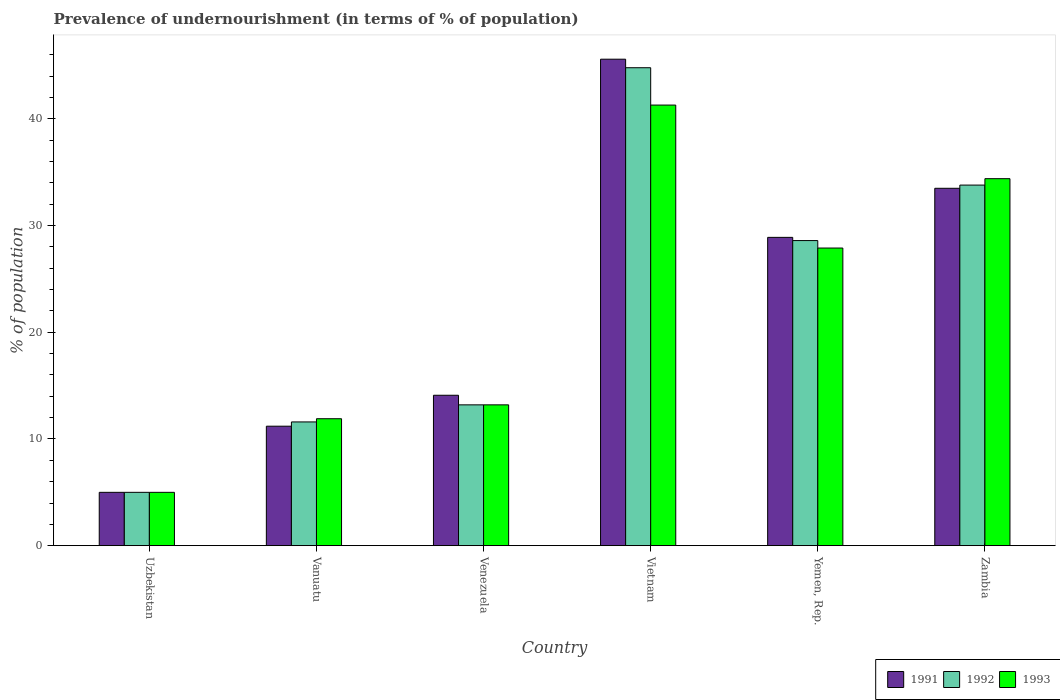How many groups of bars are there?
Make the answer very short. 6. Are the number of bars per tick equal to the number of legend labels?
Provide a short and direct response. Yes. How many bars are there on the 1st tick from the left?
Make the answer very short. 3. What is the label of the 5th group of bars from the left?
Make the answer very short. Yemen, Rep. In how many cases, is the number of bars for a given country not equal to the number of legend labels?
Give a very brief answer. 0. What is the percentage of undernourished population in 1993 in Venezuela?
Offer a very short reply. 13.2. Across all countries, what is the maximum percentage of undernourished population in 1991?
Provide a succinct answer. 45.6. In which country was the percentage of undernourished population in 1993 maximum?
Offer a very short reply. Vietnam. In which country was the percentage of undernourished population in 1993 minimum?
Your answer should be very brief. Uzbekistan. What is the total percentage of undernourished population in 1991 in the graph?
Your answer should be very brief. 138.3. What is the difference between the percentage of undernourished population in 1991 in Venezuela and that in Zambia?
Keep it short and to the point. -19.4. What is the difference between the percentage of undernourished population in 1991 in Venezuela and the percentage of undernourished population in 1993 in Zambia?
Offer a very short reply. -20.3. What is the average percentage of undernourished population in 1991 per country?
Provide a short and direct response. 23.05. What is the difference between the percentage of undernourished population of/in 1991 and percentage of undernourished population of/in 1993 in Venezuela?
Your response must be concise. 0.9. What is the ratio of the percentage of undernourished population in 1992 in Venezuela to that in Yemen, Rep.?
Provide a short and direct response. 0.46. Is the percentage of undernourished population in 1991 in Uzbekistan less than that in Vanuatu?
Make the answer very short. Yes. Is the difference between the percentage of undernourished population in 1991 in Vanuatu and Vietnam greater than the difference between the percentage of undernourished population in 1993 in Vanuatu and Vietnam?
Provide a succinct answer. No. What is the difference between the highest and the second highest percentage of undernourished population in 1991?
Keep it short and to the point. 4.6. What is the difference between the highest and the lowest percentage of undernourished population in 1992?
Offer a terse response. 39.8. In how many countries, is the percentage of undernourished population in 1993 greater than the average percentage of undernourished population in 1993 taken over all countries?
Your answer should be very brief. 3. Is the sum of the percentage of undernourished population in 1992 in Uzbekistan and Vanuatu greater than the maximum percentage of undernourished population in 1993 across all countries?
Offer a terse response. No. Is it the case that in every country, the sum of the percentage of undernourished population in 1993 and percentage of undernourished population in 1991 is greater than the percentage of undernourished population in 1992?
Make the answer very short. Yes. How many bars are there?
Provide a short and direct response. 18. Are all the bars in the graph horizontal?
Offer a very short reply. No. How many countries are there in the graph?
Your answer should be compact. 6. Where does the legend appear in the graph?
Provide a short and direct response. Bottom right. What is the title of the graph?
Offer a very short reply. Prevalence of undernourishment (in terms of % of population). What is the label or title of the X-axis?
Keep it short and to the point. Country. What is the label or title of the Y-axis?
Make the answer very short. % of population. What is the % of population in 1993 in Uzbekistan?
Ensure brevity in your answer.  5. What is the % of population of 1991 in Vanuatu?
Your answer should be very brief. 11.2. What is the % of population of 1992 in Vanuatu?
Your response must be concise. 11.6. What is the % of population of 1991 in Venezuela?
Ensure brevity in your answer.  14.1. What is the % of population in 1992 in Venezuela?
Your answer should be compact. 13.2. What is the % of population in 1993 in Venezuela?
Give a very brief answer. 13.2. What is the % of population of 1991 in Vietnam?
Your answer should be compact. 45.6. What is the % of population in 1992 in Vietnam?
Provide a succinct answer. 44.8. What is the % of population in 1993 in Vietnam?
Your answer should be very brief. 41.3. What is the % of population of 1991 in Yemen, Rep.?
Provide a short and direct response. 28.9. What is the % of population in 1992 in Yemen, Rep.?
Your answer should be very brief. 28.6. What is the % of population of 1993 in Yemen, Rep.?
Provide a succinct answer. 27.9. What is the % of population of 1991 in Zambia?
Offer a very short reply. 33.5. What is the % of population of 1992 in Zambia?
Offer a terse response. 33.8. What is the % of population in 1993 in Zambia?
Provide a succinct answer. 34.4. Across all countries, what is the maximum % of population of 1991?
Your response must be concise. 45.6. Across all countries, what is the maximum % of population in 1992?
Your response must be concise. 44.8. Across all countries, what is the maximum % of population in 1993?
Provide a succinct answer. 41.3. Across all countries, what is the minimum % of population in 1992?
Ensure brevity in your answer.  5. Across all countries, what is the minimum % of population of 1993?
Keep it short and to the point. 5. What is the total % of population in 1991 in the graph?
Offer a terse response. 138.3. What is the total % of population of 1992 in the graph?
Your answer should be compact. 137. What is the total % of population in 1993 in the graph?
Make the answer very short. 133.7. What is the difference between the % of population of 1993 in Uzbekistan and that in Vanuatu?
Keep it short and to the point. -6.9. What is the difference between the % of population of 1991 in Uzbekistan and that in Venezuela?
Your answer should be compact. -9.1. What is the difference between the % of population of 1992 in Uzbekistan and that in Venezuela?
Offer a very short reply. -8.2. What is the difference between the % of population in 1993 in Uzbekistan and that in Venezuela?
Offer a terse response. -8.2. What is the difference between the % of population of 1991 in Uzbekistan and that in Vietnam?
Provide a short and direct response. -40.6. What is the difference between the % of population in 1992 in Uzbekistan and that in Vietnam?
Your answer should be very brief. -39.8. What is the difference between the % of population in 1993 in Uzbekistan and that in Vietnam?
Provide a short and direct response. -36.3. What is the difference between the % of population in 1991 in Uzbekistan and that in Yemen, Rep.?
Ensure brevity in your answer.  -23.9. What is the difference between the % of population in 1992 in Uzbekistan and that in Yemen, Rep.?
Give a very brief answer. -23.6. What is the difference between the % of population in 1993 in Uzbekistan and that in Yemen, Rep.?
Ensure brevity in your answer.  -22.9. What is the difference between the % of population in 1991 in Uzbekistan and that in Zambia?
Your response must be concise. -28.5. What is the difference between the % of population in 1992 in Uzbekistan and that in Zambia?
Offer a very short reply. -28.8. What is the difference between the % of population in 1993 in Uzbekistan and that in Zambia?
Provide a short and direct response. -29.4. What is the difference between the % of population of 1991 in Vanuatu and that in Venezuela?
Your answer should be very brief. -2.9. What is the difference between the % of population in 1992 in Vanuatu and that in Venezuela?
Make the answer very short. -1.6. What is the difference between the % of population in 1991 in Vanuatu and that in Vietnam?
Ensure brevity in your answer.  -34.4. What is the difference between the % of population in 1992 in Vanuatu and that in Vietnam?
Offer a very short reply. -33.2. What is the difference between the % of population in 1993 in Vanuatu and that in Vietnam?
Provide a succinct answer. -29.4. What is the difference between the % of population in 1991 in Vanuatu and that in Yemen, Rep.?
Ensure brevity in your answer.  -17.7. What is the difference between the % of population in 1993 in Vanuatu and that in Yemen, Rep.?
Your answer should be very brief. -16. What is the difference between the % of population in 1991 in Vanuatu and that in Zambia?
Offer a very short reply. -22.3. What is the difference between the % of population of 1992 in Vanuatu and that in Zambia?
Provide a short and direct response. -22.2. What is the difference between the % of population in 1993 in Vanuatu and that in Zambia?
Your response must be concise. -22.5. What is the difference between the % of population in 1991 in Venezuela and that in Vietnam?
Your answer should be very brief. -31.5. What is the difference between the % of population of 1992 in Venezuela and that in Vietnam?
Make the answer very short. -31.6. What is the difference between the % of population in 1993 in Venezuela and that in Vietnam?
Your response must be concise. -28.1. What is the difference between the % of population in 1991 in Venezuela and that in Yemen, Rep.?
Keep it short and to the point. -14.8. What is the difference between the % of population in 1992 in Venezuela and that in Yemen, Rep.?
Offer a terse response. -15.4. What is the difference between the % of population in 1993 in Venezuela and that in Yemen, Rep.?
Provide a short and direct response. -14.7. What is the difference between the % of population in 1991 in Venezuela and that in Zambia?
Your response must be concise. -19.4. What is the difference between the % of population of 1992 in Venezuela and that in Zambia?
Your answer should be compact. -20.6. What is the difference between the % of population of 1993 in Venezuela and that in Zambia?
Offer a terse response. -21.2. What is the difference between the % of population in 1992 in Vietnam and that in Zambia?
Keep it short and to the point. 11. What is the difference between the % of population of 1991 in Uzbekistan and the % of population of 1992 in Vanuatu?
Give a very brief answer. -6.6. What is the difference between the % of population in 1991 in Uzbekistan and the % of population in 1993 in Vanuatu?
Offer a very short reply. -6.9. What is the difference between the % of population of 1992 in Uzbekistan and the % of population of 1993 in Vanuatu?
Provide a short and direct response. -6.9. What is the difference between the % of population in 1992 in Uzbekistan and the % of population in 1993 in Venezuela?
Your answer should be compact. -8.2. What is the difference between the % of population in 1991 in Uzbekistan and the % of population in 1992 in Vietnam?
Provide a short and direct response. -39.8. What is the difference between the % of population of 1991 in Uzbekistan and the % of population of 1993 in Vietnam?
Provide a short and direct response. -36.3. What is the difference between the % of population of 1992 in Uzbekistan and the % of population of 1993 in Vietnam?
Provide a short and direct response. -36.3. What is the difference between the % of population of 1991 in Uzbekistan and the % of population of 1992 in Yemen, Rep.?
Offer a terse response. -23.6. What is the difference between the % of population of 1991 in Uzbekistan and the % of population of 1993 in Yemen, Rep.?
Your answer should be very brief. -22.9. What is the difference between the % of population in 1992 in Uzbekistan and the % of population in 1993 in Yemen, Rep.?
Your answer should be compact. -22.9. What is the difference between the % of population in 1991 in Uzbekistan and the % of population in 1992 in Zambia?
Provide a succinct answer. -28.8. What is the difference between the % of population in 1991 in Uzbekistan and the % of population in 1993 in Zambia?
Your response must be concise. -29.4. What is the difference between the % of population in 1992 in Uzbekistan and the % of population in 1993 in Zambia?
Provide a short and direct response. -29.4. What is the difference between the % of population in 1992 in Vanuatu and the % of population in 1993 in Venezuela?
Provide a short and direct response. -1.6. What is the difference between the % of population in 1991 in Vanuatu and the % of population in 1992 in Vietnam?
Your response must be concise. -33.6. What is the difference between the % of population in 1991 in Vanuatu and the % of population in 1993 in Vietnam?
Give a very brief answer. -30.1. What is the difference between the % of population of 1992 in Vanuatu and the % of population of 1993 in Vietnam?
Make the answer very short. -29.7. What is the difference between the % of population in 1991 in Vanuatu and the % of population in 1992 in Yemen, Rep.?
Your response must be concise. -17.4. What is the difference between the % of population in 1991 in Vanuatu and the % of population in 1993 in Yemen, Rep.?
Provide a succinct answer. -16.7. What is the difference between the % of population in 1992 in Vanuatu and the % of population in 1993 in Yemen, Rep.?
Offer a terse response. -16.3. What is the difference between the % of population of 1991 in Vanuatu and the % of population of 1992 in Zambia?
Give a very brief answer. -22.6. What is the difference between the % of population of 1991 in Vanuatu and the % of population of 1993 in Zambia?
Ensure brevity in your answer.  -23.2. What is the difference between the % of population of 1992 in Vanuatu and the % of population of 1993 in Zambia?
Your answer should be very brief. -22.8. What is the difference between the % of population in 1991 in Venezuela and the % of population in 1992 in Vietnam?
Keep it short and to the point. -30.7. What is the difference between the % of population of 1991 in Venezuela and the % of population of 1993 in Vietnam?
Your response must be concise. -27.2. What is the difference between the % of population in 1992 in Venezuela and the % of population in 1993 in Vietnam?
Make the answer very short. -28.1. What is the difference between the % of population of 1991 in Venezuela and the % of population of 1993 in Yemen, Rep.?
Offer a terse response. -13.8. What is the difference between the % of population of 1992 in Venezuela and the % of population of 1993 in Yemen, Rep.?
Your answer should be very brief. -14.7. What is the difference between the % of population in 1991 in Venezuela and the % of population in 1992 in Zambia?
Ensure brevity in your answer.  -19.7. What is the difference between the % of population of 1991 in Venezuela and the % of population of 1993 in Zambia?
Make the answer very short. -20.3. What is the difference between the % of population in 1992 in Venezuela and the % of population in 1993 in Zambia?
Offer a terse response. -21.2. What is the difference between the % of population of 1991 in Vietnam and the % of population of 1992 in Yemen, Rep.?
Keep it short and to the point. 17. What is the difference between the % of population in 1991 in Vietnam and the % of population in 1993 in Yemen, Rep.?
Your answer should be compact. 17.7. What is the difference between the % of population of 1991 in Vietnam and the % of population of 1992 in Zambia?
Keep it short and to the point. 11.8. What is the difference between the % of population in 1991 in Yemen, Rep. and the % of population in 1993 in Zambia?
Your answer should be very brief. -5.5. What is the average % of population of 1991 per country?
Give a very brief answer. 23.05. What is the average % of population in 1992 per country?
Provide a short and direct response. 22.83. What is the average % of population in 1993 per country?
Provide a short and direct response. 22.28. What is the difference between the % of population of 1992 and % of population of 1993 in Uzbekistan?
Give a very brief answer. 0. What is the difference between the % of population in 1992 and % of population in 1993 in Vanuatu?
Offer a terse response. -0.3. What is the difference between the % of population in 1991 and % of population in 1992 in Venezuela?
Offer a very short reply. 0.9. What is the difference between the % of population in 1991 and % of population in 1993 in Venezuela?
Provide a short and direct response. 0.9. What is the difference between the % of population of 1992 and % of population of 1993 in Venezuela?
Make the answer very short. 0. What is the difference between the % of population of 1991 and % of population of 1992 in Vietnam?
Your response must be concise. 0.8. What is the difference between the % of population in 1991 and % of population in 1993 in Vietnam?
Offer a very short reply. 4.3. What is the difference between the % of population of 1992 and % of population of 1993 in Vietnam?
Provide a short and direct response. 3.5. What is the difference between the % of population of 1991 and % of population of 1992 in Yemen, Rep.?
Ensure brevity in your answer.  0.3. What is the difference between the % of population in 1991 and % of population in 1993 in Zambia?
Ensure brevity in your answer.  -0.9. What is the ratio of the % of population in 1991 in Uzbekistan to that in Vanuatu?
Ensure brevity in your answer.  0.45. What is the ratio of the % of population of 1992 in Uzbekistan to that in Vanuatu?
Provide a short and direct response. 0.43. What is the ratio of the % of population of 1993 in Uzbekistan to that in Vanuatu?
Your response must be concise. 0.42. What is the ratio of the % of population in 1991 in Uzbekistan to that in Venezuela?
Give a very brief answer. 0.35. What is the ratio of the % of population of 1992 in Uzbekistan to that in Venezuela?
Ensure brevity in your answer.  0.38. What is the ratio of the % of population in 1993 in Uzbekistan to that in Venezuela?
Your response must be concise. 0.38. What is the ratio of the % of population of 1991 in Uzbekistan to that in Vietnam?
Provide a short and direct response. 0.11. What is the ratio of the % of population in 1992 in Uzbekistan to that in Vietnam?
Provide a short and direct response. 0.11. What is the ratio of the % of population in 1993 in Uzbekistan to that in Vietnam?
Give a very brief answer. 0.12. What is the ratio of the % of population in 1991 in Uzbekistan to that in Yemen, Rep.?
Provide a short and direct response. 0.17. What is the ratio of the % of population in 1992 in Uzbekistan to that in Yemen, Rep.?
Your answer should be compact. 0.17. What is the ratio of the % of population in 1993 in Uzbekistan to that in Yemen, Rep.?
Ensure brevity in your answer.  0.18. What is the ratio of the % of population of 1991 in Uzbekistan to that in Zambia?
Give a very brief answer. 0.15. What is the ratio of the % of population of 1992 in Uzbekistan to that in Zambia?
Your answer should be very brief. 0.15. What is the ratio of the % of population of 1993 in Uzbekistan to that in Zambia?
Provide a short and direct response. 0.15. What is the ratio of the % of population in 1991 in Vanuatu to that in Venezuela?
Make the answer very short. 0.79. What is the ratio of the % of population in 1992 in Vanuatu to that in Venezuela?
Your answer should be very brief. 0.88. What is the ratio of the % of population in 1993 in Vanuatu to that in Venezuela?
Keep it short and to the point. 0.9. What is the ratio of the % of population of 1991 in Vanuatu to that in Vietnam?
Keep it short and to the point. 0.25. What is the ratio of the % of population in 1992 in Vanuatu to that in Vietnam?
Offer a very short reply. 0.26. What is the ratio of the % of population of 1993 in Vanuatu to that in Vietnam?
Give a very brief answer. 0.29. What is the ratio of the % of population of 1991 in Vanuatu to that in Yemen, Rep.?
Your response must be concise. 0.39. What is the ratio of the % of population of 1992 in Vanuatu to that in Yemen, Rep.?
Provide a succinct answer. 0.41. What is the ratio of the % of population of 1993 in Vanuatu to that in Yemen, Rep.?
Make the answer very short. 0.43. What is the ratio of the % of population in 1991 in Vanuatu to that in Zambia?
Provide a short and direct response. 0.33. What is the ratio of the % of population in 1992 in Vanuatu to that in Zambia?
Your answer should be compact. 0.34. What is the ratio of the % of population of 1993 in Vanuatu to that in Zambia?
Make the answer very short. 0.35. What is the ratio of the % of population of 1991 in Venezuela to that in Vietnam?
Make the answer very short. 0.31. What is the ratio of the % of population in 1992 in Venezuela to that in Vietnam?
Your answer should be compact. 0.29. What is the ratio of the % of population of 1993 in Venezuela to that in Vietnam?
Give a very brief answer. 0.32. What is the ratio of the % of population of 1991 in Venezuela to that in Yemen, Rep.?
Keep it short and to the point. 0.49. What is the ratio of the % of population in 1992 in Venezuela to that in Yemen, Rep.?
Offer a terse response. 0.46. What is the ratio of the % of population of 1993 in Venezuela to that in Yemen, Rep.?
Give a very brief answer. 0.47. What is the ratio of the % of population of 1991 in Venezuela to that in Zambia?
Give a very brief answer. 0.42. What is the ratio of the % of population in 1992 in Venezuela to that in Zambia?
Your response must be concise. 0.39. What is the ratio of the % of population in 1993 in Venezuela to that in Zambia?
Your response must be concise. 0.38. What is the ratio of the % of population in 1991 in Vietnam to that in Yemen, Rep.?
Offer a very short reply. 1.58. What is the ratio of the % of population in 1992 in Vietnam to that in Yemen, Rep.?
Make the answer very short. 1.57. What is the ratio of the % of population in 1993 in Vietnam to that in Yemen, Rep.?
Ensure brevity in your answer.  1.48. What is the ratio of the % of population of 1991 in Vietnam to that in Zambia?
Make the answer very short. 1.36. What is the ratio of the % of population of 1992 in Vietnam to that in Zambia?
Offer a terse response. 1.33. What is the ratio of the % of population of 1993 in Vietnam to that in Zambia?
Ensure brevity in your answer.  1.2. What is the ratio of the % of population of 1991 in Yemen, Rep. to that in Zambia?
Make the answer very short. 0.86. What is the ratio of the % of population of 1992 in Yemen, Rep. to that in Zambia?
Your answer should be compact. 0.85. What is the ratio of the % of population in 1993 in Yemen, Rep. to that in Zambia?
Make the answer very short. 0.81. What is the difference between the highest and the lowest % of population in 1991?
Keep it short and to the point. 40.6. What is the difference between the highest and the lowest % of population in 1992?
Offer a terse response. 39.8. What is the difference between the highest and the lowest % of population of 1993?
Provide a succinct answer. 36.3. 